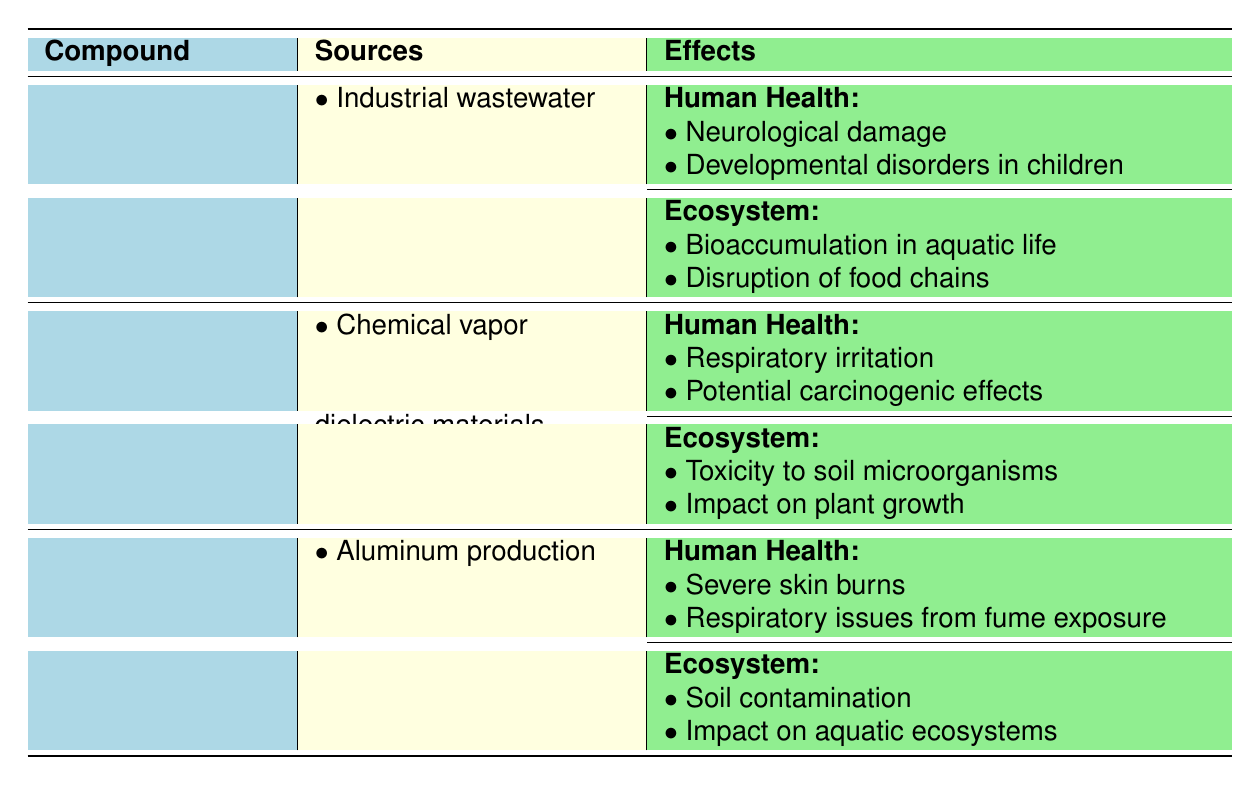What are the sources of Methylmercury? The table lists the sources of Methylmercury under the "Sources" column. These sources are "Industrial wastewater" and "Burning of municipal waste."
Answer: Industrial wastewater, Burning of municipal waste Which compound has respiratory irritation as an effect on human health? By reviewing the "Human Health" effects for each compound, it is evident that "Respiratory irritation" is listed under Tetrakismethylcyclopentadienylhafnium(IV).
Answer: Tetrakismethylcyclopentadienylhafnium(IV) Does Triethylaluminum affect aquatic ecosystems? The effects on ecosystems for Triethylaluminum show "Impact on aquatic ecosystems," confirming that it does affect aquatic life.
Answer: Yes What is the total number of human health effects reported for organometallic compounds in the table? There are 2 human health effects listed for each of the 3 compounds, totaling 6 (2 + 2 + 2 = 6).
Answer: 6 Which organometallic compound is associated with soil contamination? Under the "Ecosystem" effects for Triethylaluminum, it specifically mentions "Soil contamination." Therefore, Triethylaluminum is associated with this effect.
Answer: Triethylaluminum What are the common sources of organometallic compounds listed in the table? By aggregating the sources from all three compounds, the unique sources listed are: "Industrial wastewater," "Burning of municipal waste," "Chemical vapor deposition processes," "Production of high-k dielectric materials," "Aluminum production," and "Polymer manufacturing."
Answer: Industrial wastewater, Burning of municipal waste, Chemical vapor deposition processes, Production of high-k dielectric materials, Aluminum production, Polymer manufacturing Are there any effects on plant growth mentioned for Tetrakismethylcyclopentadienylhafnium(IV)? The table clearly lists "Impact on plant growth" as one of the ecosystem effects under Tetrakismethylcyclopentadienylhafnium(IV), confirming the presence of this effect.
Answer: Yes What is the difference in the total number of human health effects between Methylmercury and Triethylaluminum? Each compound has 2 human health effects, thus the difference is 2 - 2 = 0.
Answer: 0 Which organometallic compound has the most complex source description based on how they are written? The sources for Tetrakismethylcyclopentadienylhafnium(IV) are the most complexly described, listing two distinct processes: "Chemical vapor deposition processes" and "Production of high-k dielectric materials."
Answer: Tetrakismethylcyclopentadienylhafnium(IV) 